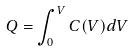Convert formula to latex. <formula><loc_0><loc_0><loc_500><loc_500>Q = \int _ { 0 } ^ { V } C ( V ) d V</formula> 